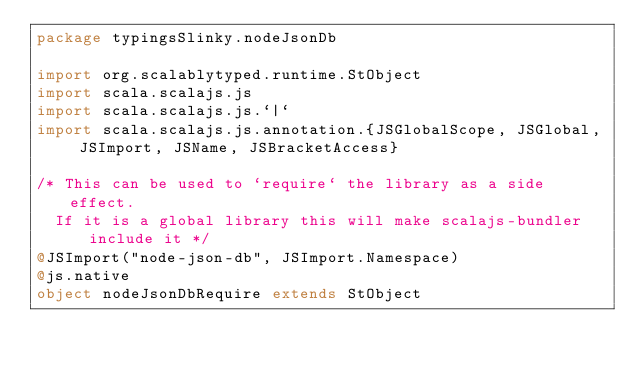<code> <loc_0><loc_0><loc_500><loc_500><_Scala_>package typingsSlinky.nodeJsonDb

import org.scalablytyped.runtime.StObject
import scala.scalajs.js
import scala.scalajs.js.`|`
import scala.scalajs.js.annotation.{JSGlobalScope, JSGlobal, JSImport, JSName, JSBracketAccess}

/* This can be used to `require` the library as a side effect.
  If it is a global library this will make scalajs-bundler include it */
@JSImport("node-json-db", JSImport.Namespace)
@js.native
object nodeJsonDbRequire extends StObject
</code> 